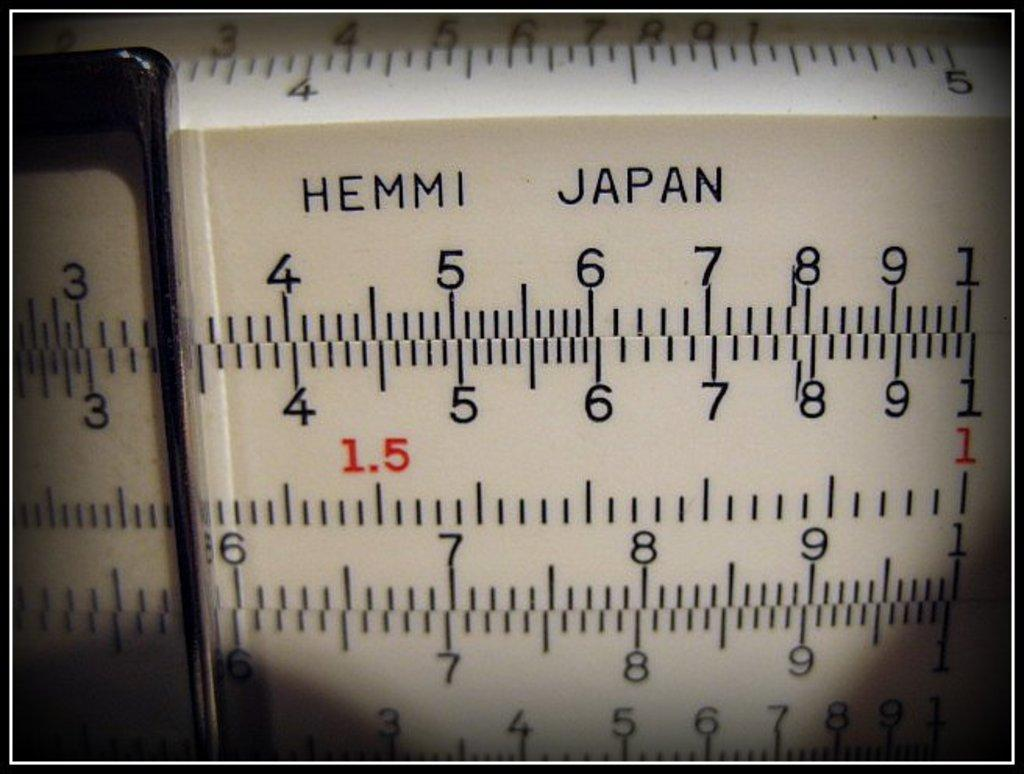Provide a one-sentence caption for the provided image. Hemmi Japan that contains numbers that are black and red. 